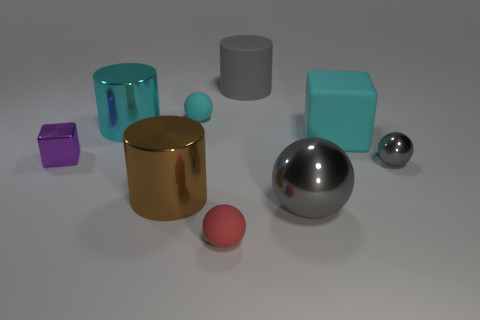Subtract all blocks. How many objects are left? 7 Subtract all gray metal objects. Subtract all small rubber things. How many objects are left? 5 Add 2 large gray objects. How many large gray objects are left? 4 Add 8 large yellow metallic balls. How many large yellow metallic balls exist? 8 Subtract 0 green cylinders. How many objects are left? 9 